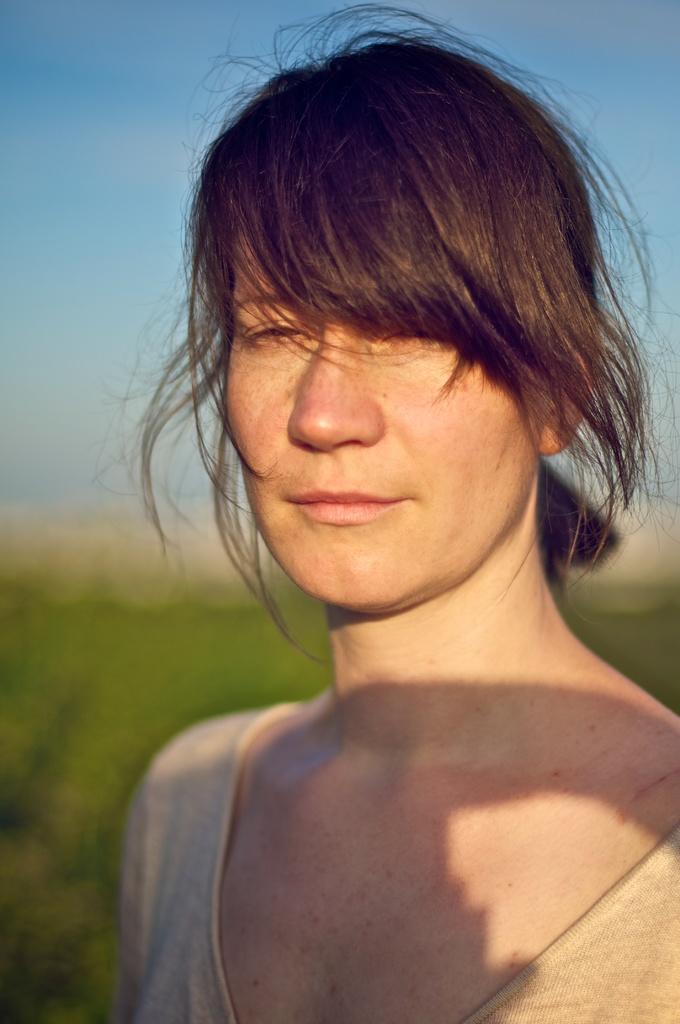Could you give a brief overview of what you see in this image? In this image, we can see a woman. Background there is a blur view. Here we can see green and blue colors. 